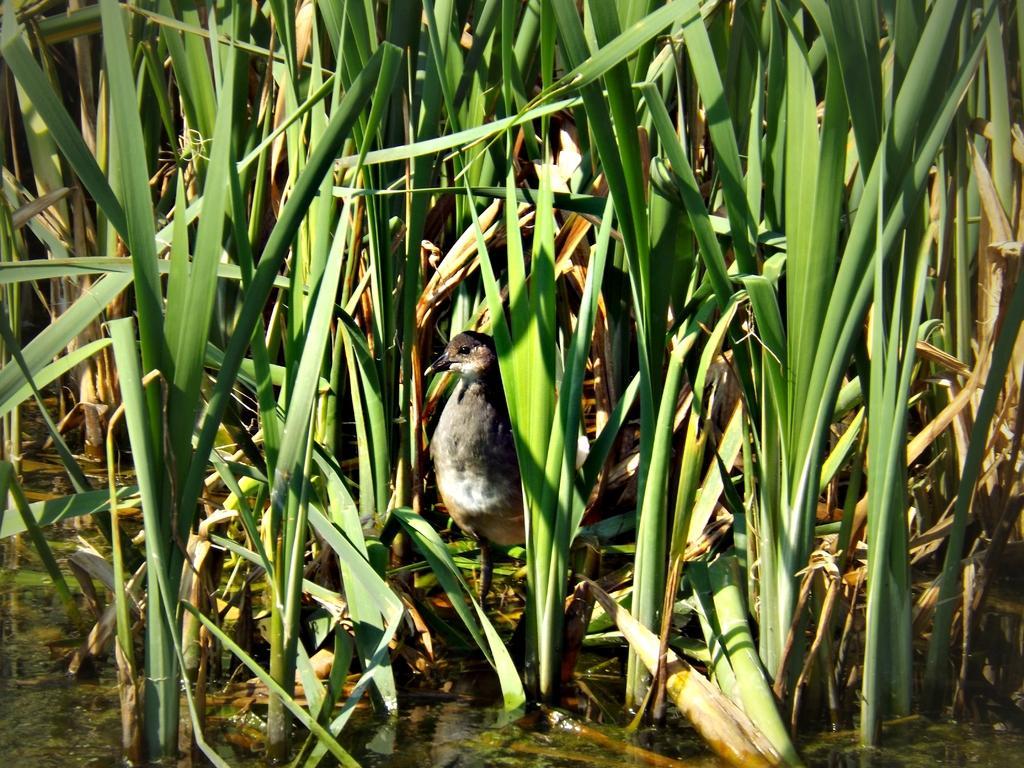Can you describe this image briefly? In this picture there is a bird standing near to the water. At the top we can see plants. On the left we can see the leaves. 